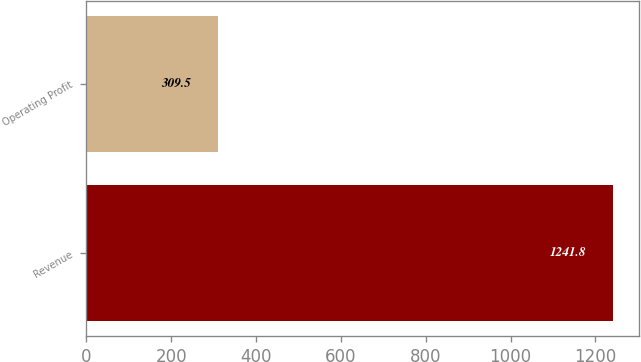<chart> <loc_0><loc_0><loc_500><loc_500><bar_chart><fcel>Revenue<fcel>Operating Profit<nl><fcel>1241.8<fcel>309.5<nl></chart> 